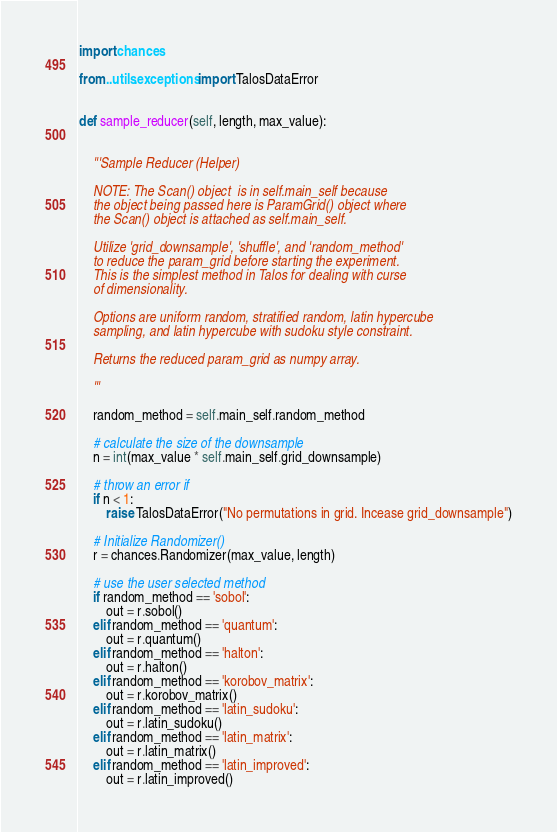Convert code to text. <code><loc_0><loc_0><loc_500><loc_500><_Python_>import chances

from ..utils.exceptions import TalosDataError


def sample_reducer(self, length, max_value):


    '''Sample Reducer (Helper)

    NOTE: The Scan() object  is in self.main_self because
    the object being passed here is ParamGrid() object where
    the Scan() object is attached as self.main_self.

    Utilize 'grid_downsample', 'shuffle', and 'random_method'
    to reduce the param_grid before starting the experiment.
    This is the simplest method in Talos for dealing with curse
    of dimensionality.

    Options are uniform random, stratified random, latin hypercube
    sampling, and latin hypercube with sudoku style constraint.

    Returns the reduced param_grid as numpy array.

    '''

    random_method = self.main_self.random_method

    # calculate the size of the downsample
    n = int(max_value * self.main_self.grid_downsample)

    # throw an error if
    if n < 1:
        raise TalosDataError("No permutations in grid. Incease grid_downsample")

    # Initialize Randomizer()
    r = chances.Randomizer(max_value, length)

    # use the user selected method
    if random_method == 'sobol':
        out = r.sobol()
    elif random_method == 'quantum':
        out = r.quantum()
    elif random_method == 'halton':
        out = r.halton()
    elif random_method == 'korobov_matrix':
        out = r.korobov_matrix()
    elif random_method == 'latin_sudoku':
        out = r.latin_sudoku()
    elif random_method == 'latin_matrix':
        out = r.latin_matrix()
    elif random_method == 'latin_improved':
        out = r.latin_improved()</code> 